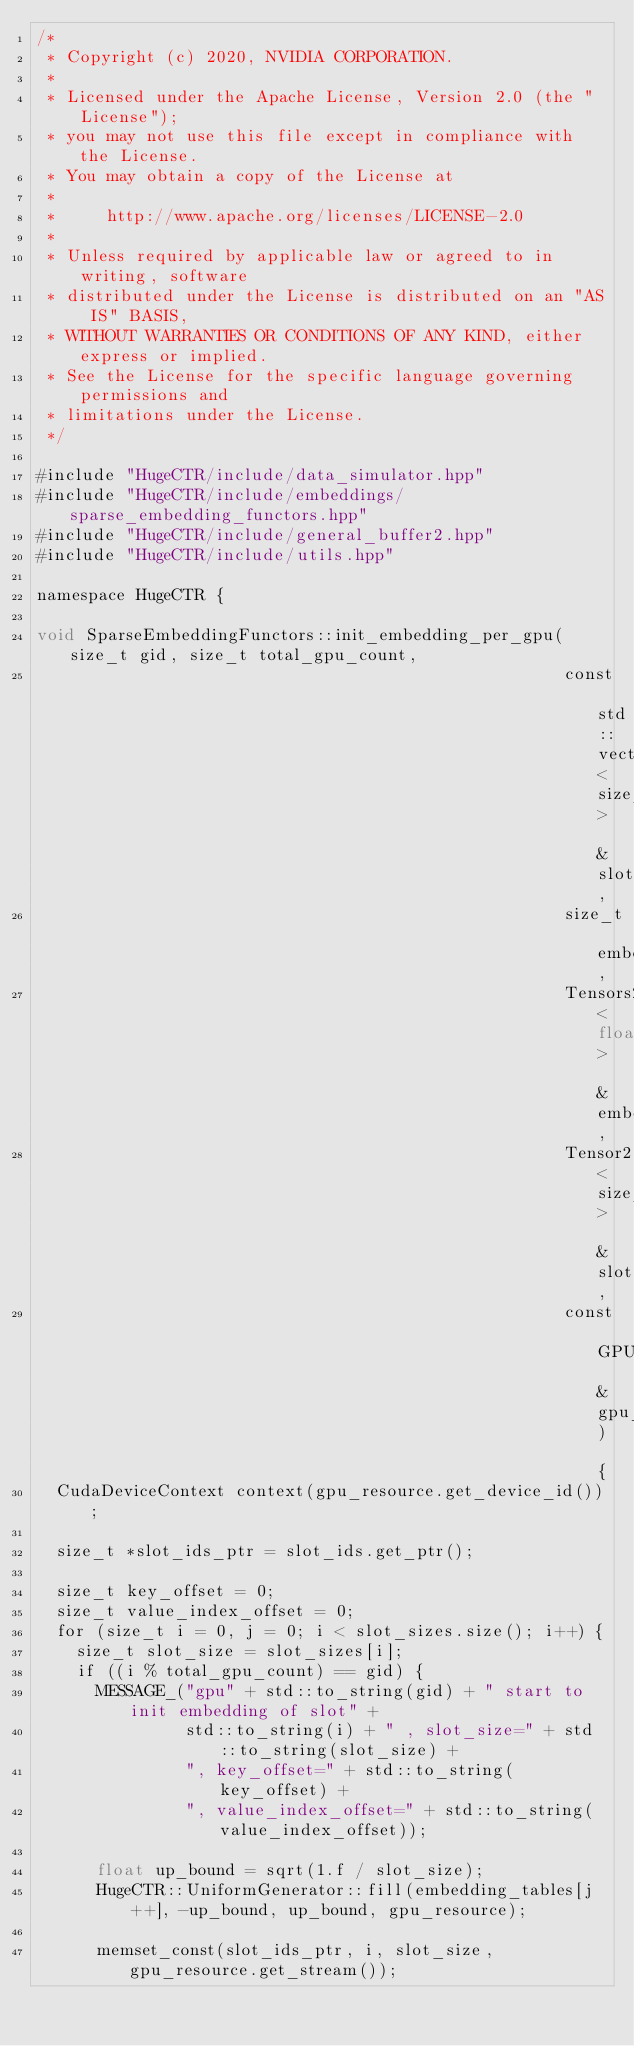Convert code to text. <code><loc_0><loc_0><loc_500><loc_500><_Cuda_>/*
 * Copyright (c) 2020, NVIDIA CORPORATION.
 *
 * Licensed under the Apache License, Version 2.0 (the "License");
 * you may not use this file except in compliance with the License.
 * You may obtain a copy of the License at
 *
 *     http://www.apache.org/licenses/LICENSE-2.0
 *
 * Unless required by applicable law or agreed to in writing, software
 * distributed under the License is distributed on an "AS IS" BASIS,
 * WITHOUT WARRANTIES OR CONDITIONS OF ANY KIND, either express or implied.
 * See the License for the specific language governing permissions and
 * limitations under the License.
 */

#include "HugeCTR/include/data_simulator.hpp"
#include "HugeCTR/include/embeddings/sparse_embedding_functors.hpp"
#include "HugeCTR/include/general_buffer2.hpp"
#include "HugeCTR/include/utils.hpp"

namespace HugeCTR {

void SparseEmbeddingFunctors::init_embedding_per_gpu(size_t gid, size_t total_gpu_count,
                                                     const std::vector<size_t> &slot_sizes,
                                                     size_t embedding_vec_size,
                                                     Tensors2<float> &embedding_tables,
                                                     Tensor2<size_t> &slot_ids,
                                                     const GPUResource &gpu_resource) {
  CudaDeviceContext context(gpu_resource.get_device_id());

  size_t *slot_ids_ptr = slot_ids.get_ptr();

  size_t key_offset = 0;
  size_t value_index_offset = 0;
  for (size_t i = 0, j = 0; i < slot_sizes.size(); i++) {
    size_t slot_size = slot_sizes[i];
    if ((i % total_gpu_count) == gid) {
      MESSAGE_("gpu" + std::to_string(gid) + " start to init embedding of slot" +
               std::to_string(i) + " , slot_size=" + std::to_string(slot_size) +
               ", key_offset=" + std::to_string(key_offset) +
               ", value_index_offset=" + std::to_string(value_index_offset));

      float up_bound = sqrt(1.f / slot_size);
      HugeCTR::UniformGenerator::fill(embedding_tables[j++], -up_bound, up_bound, gpu_resource);

      memset_const(slot_ids_ptr, i, slot_size, gpu_resource.get_stream());
</code> 